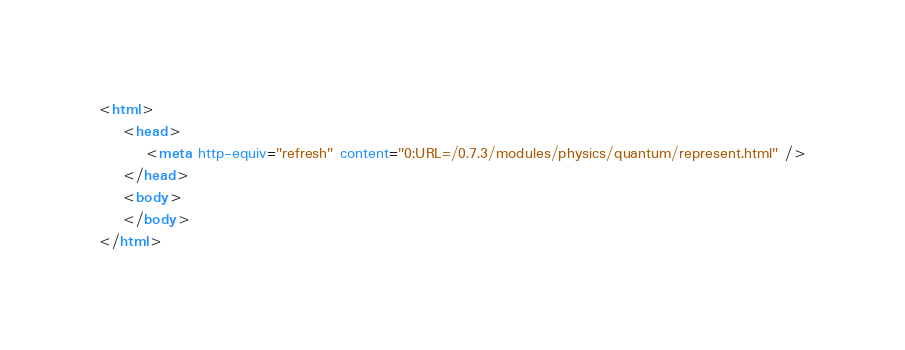Convert code to text. <code><loc_0><loc_0><loc_500><loc_500><_HTML_><html>
    <head>
        <meta http-equiv="refresh" content="0;URL=/0.7.3/modules/physics/quantum/represent.html" />
    </head>
    <body>
    </body>
</html>

</code> 